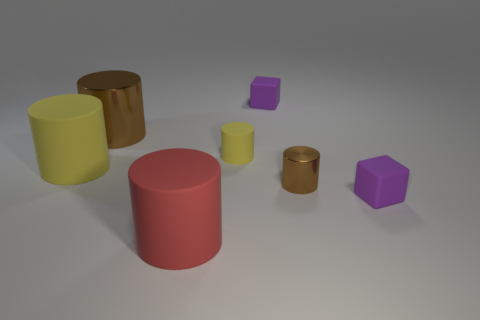Subtract all red cylinders. How many cylinders are left? 4 Subtract all large red cylinders. How many cylinders are left? 4 Subtract all blue cylinders. Subtract all green cubes. How many cylinders are left? 5 Add 1 shiny cylinders. How many objects exist? 8 Subtract all cubes. How many objects are left? 5 Add 7 small brown shiny cylinders. How many small brown shiny cylinders are left? 8 Add 6 small yellow matte cylinders. How many small yellow matte cylinders exist? 7 Subtract 0 gray spheres. How many objects are left? 7 Subtract all small things. Subtract all tiny brown rubber cylinders. How many objects are left? 3 